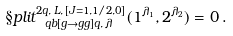Convert formula to latex. <formula><loc_0><loc_0><loc_500><loc_500>\S p l i t ^ { 2 q , \, L , \, [ J = 1 , 1 / 2 , 0 ] } _ { \ q b [ g \to g g ] q , \, \lambda } ( 1 ^ { \lambda _ { 1 } } , 2 ^ { \lambda _ { 2 } } ) = 0 \, .</formula> 